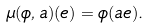<formula> <loc_0><loc_0><loc_500><loc_500>\mu ( \phi , a ) ( e ) = \phi ( a e ) .</formula> 